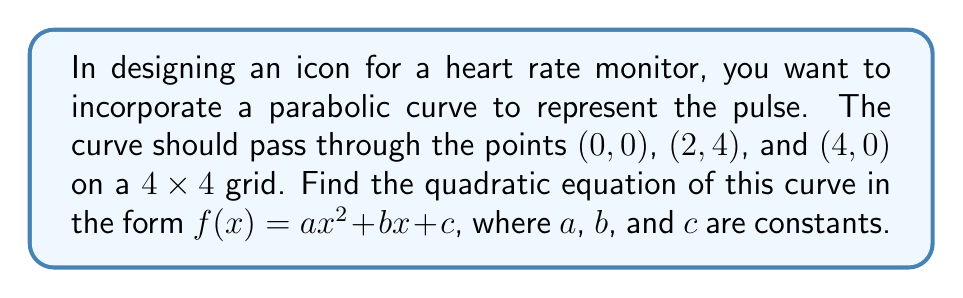Help me with this question. Let's approach this step-by-step:

1) The general form of a quadratic equation is $f(x) = ax^2 + bx + c$, where $a$, $b$, and $c$ are constants we need to determine.

2) We know the curve passes through three points: (0, 0), (2, 4), and (4, 0). Let's use these to create a system of equations:

   For (0, 0): $0 = a(0)^2 + b(0) + c$, which simplifies to $c = 0$

   For (2, 4): $4 = a(2)^2 + b(2) + 0$, or $4 = 4a + 2b$

   For (4, 0): $0 = a(4)^2 + b(4) + 0$, or $0 = 16a + 4b$

3) From the first equation, we know $c = 0$. Now we have two equations with two unknowns:

   $4 = 4a + 2b$
   $0 = 16a + 4b$

4) Multiply the first equation by 2:

   $8 = 8a + 4b$
   $0 = 16a + 4b$

5) Subtract the second equation from the first:

   $8 = -8a$

6) Solve for $a$:

   $a = -1$

7) Substitute this back into $4 = 4a + 2b$:

   $4 = 4(-1) + 2b$
   $4 = -4 + 2b$
   $8 = 2b$
   $b = 4$

8) Therefore, the quadratic equation is:

   $f(x) = -x^2 + 4x + 0$, which simplifies to $f(x) = -x^2 + 4x$

This parabola opens downward (because $a$ is negative) and has its vertex at (2, 4), which is the peak of the pulse in the icon.
Answer: $f(x) = -x^2 + 4x$ 